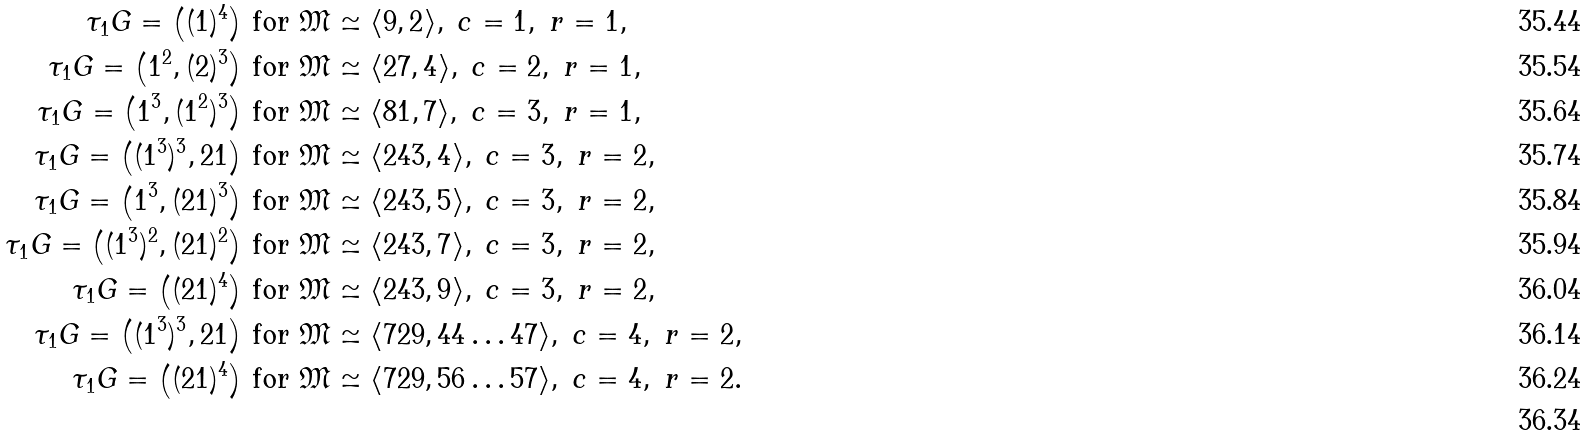<formula> <loc_0><loc_0><loc_500><loc_500>\tau _ { 1 } { G } = \left ( ( 1 ) ^ { 4 } \right ) & \text { for } \mathfrak { M } \simeq \langle 9 , 2 \rangle , \ c = 1 , \ r = 1 , \\ \tau _ { 1 } { G } = \left ( 1 ^ { 2 } , ( 2 ) ^ { 3 } \right ) & \text { for } \mathfrak { M } \simeq \langle 2 7 , 4 \rangle , \ c = 2 , \ r = 1 , \\ \tau _ { 1 } { G } = \left ( 1 ^ { 3 } , ( 1 ^ { 2 } ) ^ { 3 } \right ) & \text { for } \mathfrak { M } \simeq \langle 8 1 , 7 \rangle , \ c = 3 , \ r = 1 , \\ \tau _ { 1 } { G } = \left ( ( 1 ^ { 3 } ) ^ { 3 } , 2 1 \right ) & \text { for } \mathfrak { M } \simeq \langle 2 4 3 , 4 \rangle , \ c = 3 , \ r = 2 , \\ \tau _ { 1 } { G } = \left ( 1 ^ { 3 } , ( 2 1 ) ^ { 3 } \right ) & \text { for } \mathfrak { M } \simeq \langle 2 4 3 , 5 \rangle , \ c = 3 , \ r = 2 , \\ \tau _ { 1 } { G } = \left ( ( 1 ^ { 3 } ) ^ { 2 } , ( 2 1 ) ^ { 2 } \right ) & \text { for } \mathfrak { M } \simeq \langle 2 4 3 , 7 \rangle , \ c = 3 , \ r = 2 , \\ \tau _ { 1 } { G } = \left ( ( 2 1 ) ^ { 4 } \right ) & \text { for } \mathfrak { M } \simeq \langle 2 4 3 , 9 \rangle , \ c = 3 , \ r = 2 , \\ \tau _ { 1 } { G } = \left ( ( 1 ^ { 3 } ) ^ { 3 } , 2 1 \right ) & \text { for } \mathfrak { M } \simeq \langle 7 2 9 , 4 4 \dots 4 7 \rangle , \ c = 4 , \ r = 2 , \\ \tau _ { 1 } { G } = \left ( ( 2 1 ) ^ { 4 } \right ) & \text { for } \mathfrak { M } \simeq \langle 7 2 9 , 5 6 \dots 5 7 \rangle , \ c = 4 , \ r = 2 . \\</formula> 